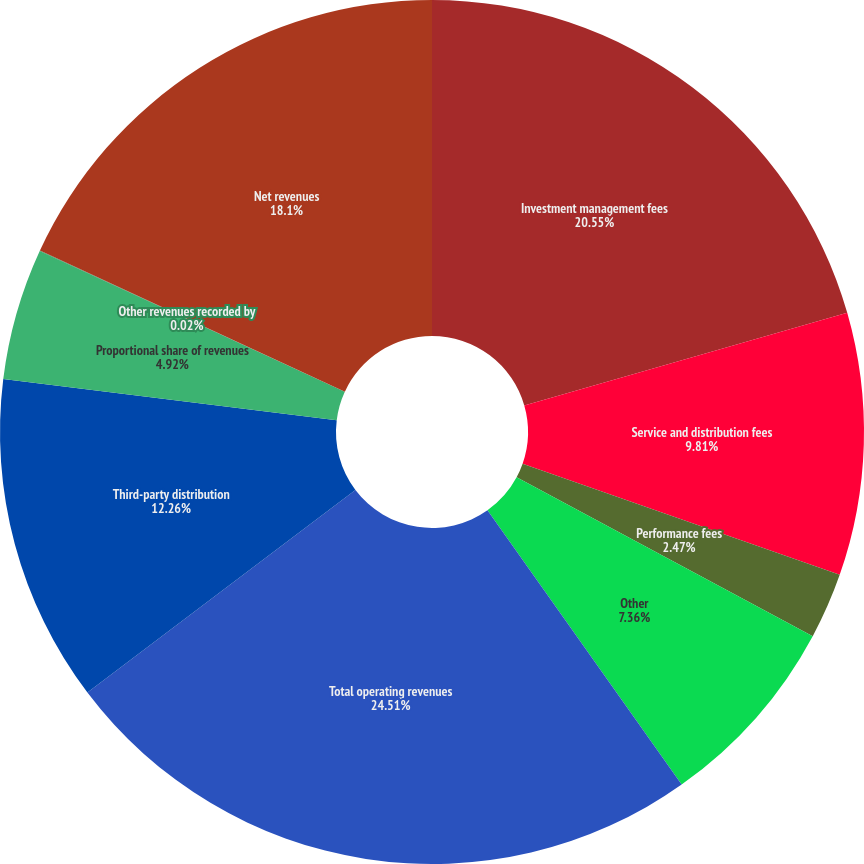<chart> <loc_0><loc_0><loc_500><loc_500><pie_chart><fcel>Investment management fees<fcel>Service and distribution fees<fcel>Performance fees<fcel>Other<fcel>Total operating revenues<fcel>Third-party distribution<fcel>Proportional share of revenues<fcel>Other revenues recorded by<fcel>Net revenues<nl><fcel>20.55%<fcel>9.81%<fcel>2.47%<fcel>7.36%<fcel>24.5%<fcel>12.26%<fcel>4.92%<fcel>0.02%<fcel>18.1%<nl></chart> 